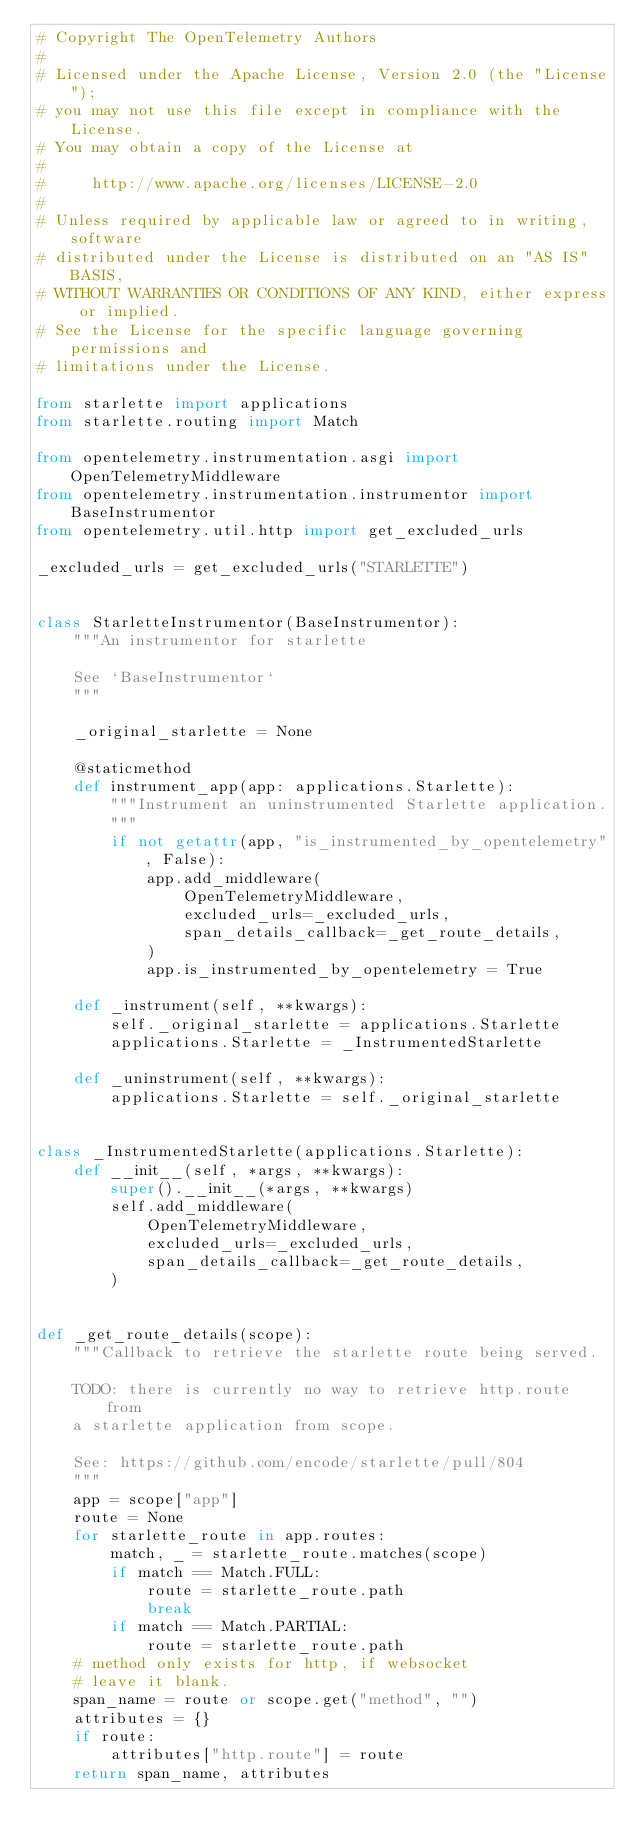<code> <loc_0><loc_0><loc_500><loc_500><_Python_># Copyright The OpenTelemetry Authors
#
# Licensed under the Apache License, Version 2.0 (the "License");
# you may not use this file except in compliance with the License.
# You may obtain a copy of the License at
#
#     http://www.apache.org/licenses/LICENSE-2.0
#
# Unless required by applicable law or agreed to in writing, software
# distributed under the License is distributed on an "AS IS" BASIS,
# WITHOUT WARRANTIES OR CONDITIONS OF ANY KIND, either express or implied.
# See the License for the specific language governing permissions and
# limitations under the License.

from starlette import applications
from starlette.routing import Match

from opentelemetry.instrumentation.asgi import OpenTelemetryMiddleware
from opentelemetry.instrumentation.instrumentor import BaseInstrumentor
from opentelemetry.util.http import get_excluded_urls

_excluded_urls = get_excluded_urls("STARLETTE")


class StarletteInstrumentor(BaseInstrumentor):
    """An instrumentor for starlette

    See `BaseInstrumentor`
    """

    _original_starlette = None

    @staticmethod
    def instrument_app(app: applications.Starlette):
        """Instrument an uninstrumented Starlette application.
        """
        if not getattr(app, "is_instrumented_by_opentelemetry", False):
            app.add_middleware(
                OpenTelemetryMiddleware,
                excluded_urls=_excluded_urls,
                span_details_callback=_get_route_details,
            )
            app.is_instrumented_by_opentelemetry = True

    def _instrument(self, **kwargs):
        self._original_starlette = applications.Starlette
        applications.Starlette = _InstrumentedStarlette

    def _uninstrument(self, **kwargs):
        applications.Starlette = self._original_starlette


class _InstrumentedStarlette(applications.Starlette):
    def __init__(self, *args, **kwargs):
        super().__init__(*args, **kwargs)
        self.add_middleware(
            OpenTelemetryMiddleware,
            excluded_urls=_excluded_urls,
            span_details_callback=_get_route_details,
        )


def _get_route_details(scope):
    """Callback to retrieve the starlette route being served.

    TODO: there is currently no way to retrieve http.route from
    a starlette application from scope.

    See: https://github.com/encode/starlette/pull/804
    """
    app = scope["app"]
    route = None
    for starlette_route in app.routes:
        match, _ = starlette_route.matches(scope)
        if match == Match.FULL:
            route = starlette_route.path
            break
        if match == Match.PARTIAL:
            route = starlette_route.path
    # method only exists for http, if websocket
    # leave it blank.
    span_name = route or scope.get("method", "")
    attributes = {}
    if route:
        attributes["http.route"] = route
    return span_name, attributes
</code> 